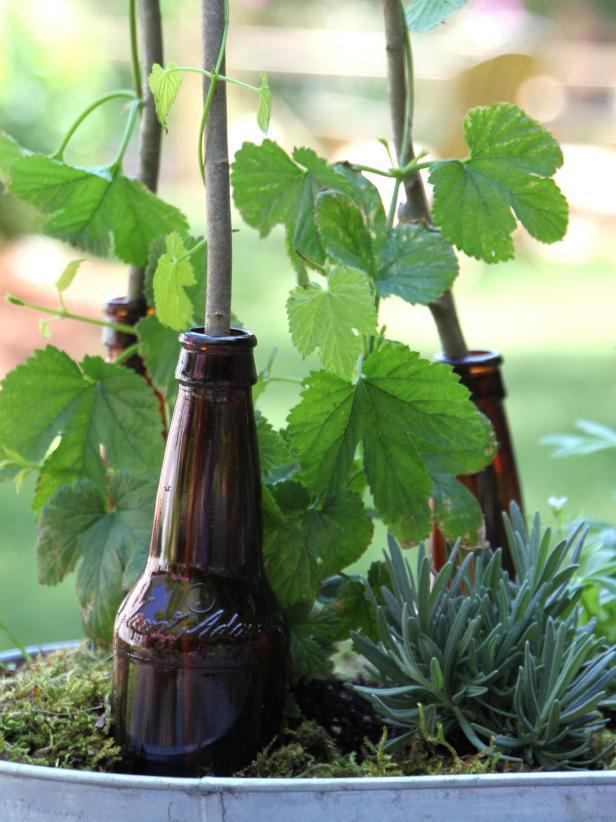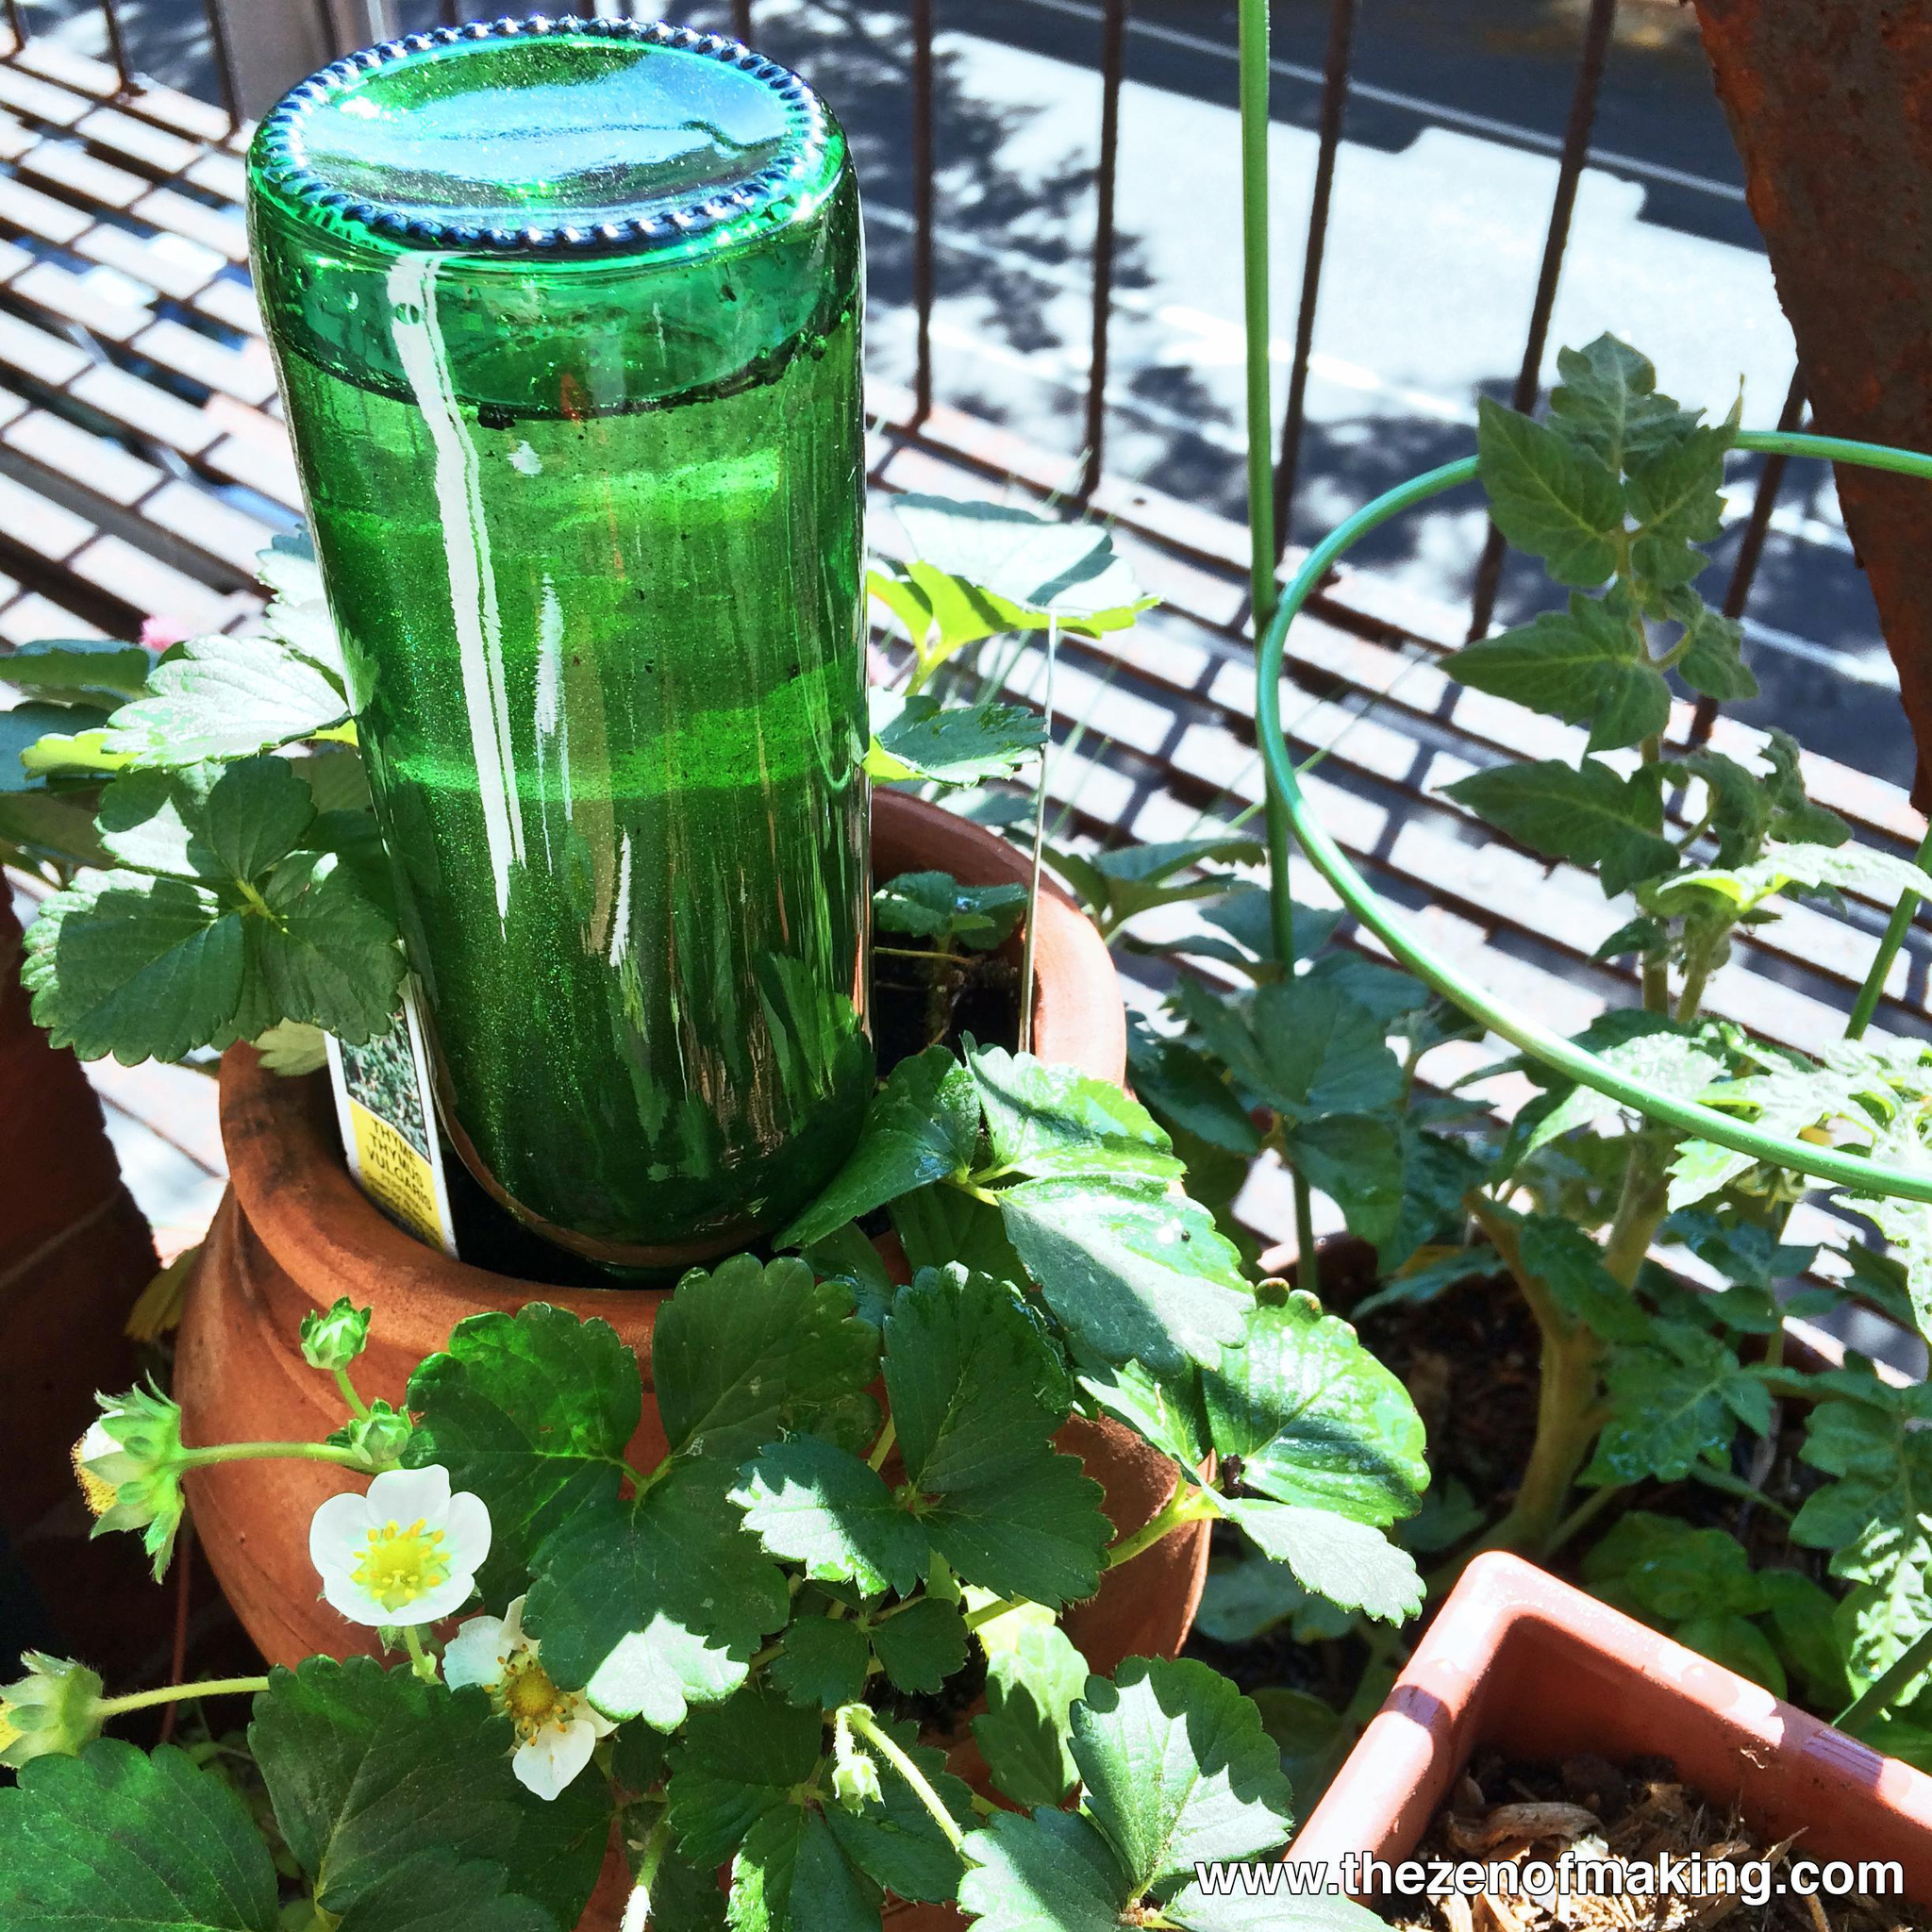The first image is the image on the left, the second image is the image on the right. For the images shown, is this caption "In at least one image there are three brown bottles with tree starting to grow out of it." true? Answer yes or no. Yes. The first image is the image on the left, the second image is the image on the right. Considering the images on both sides, is "A single bottle in the image on the right is positioned upside down." valid? Answer yes or no. Yes. 